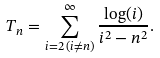<formula> <loc_0><loc_0><loc_500><loc_500>T _ { n } = \sum _ { i = 2 \, ( i \neq n ) } ^ { \infty } \frac { \log ( i ) } { i ^ { 2 } - n ^ { 2 } } .</formula> 